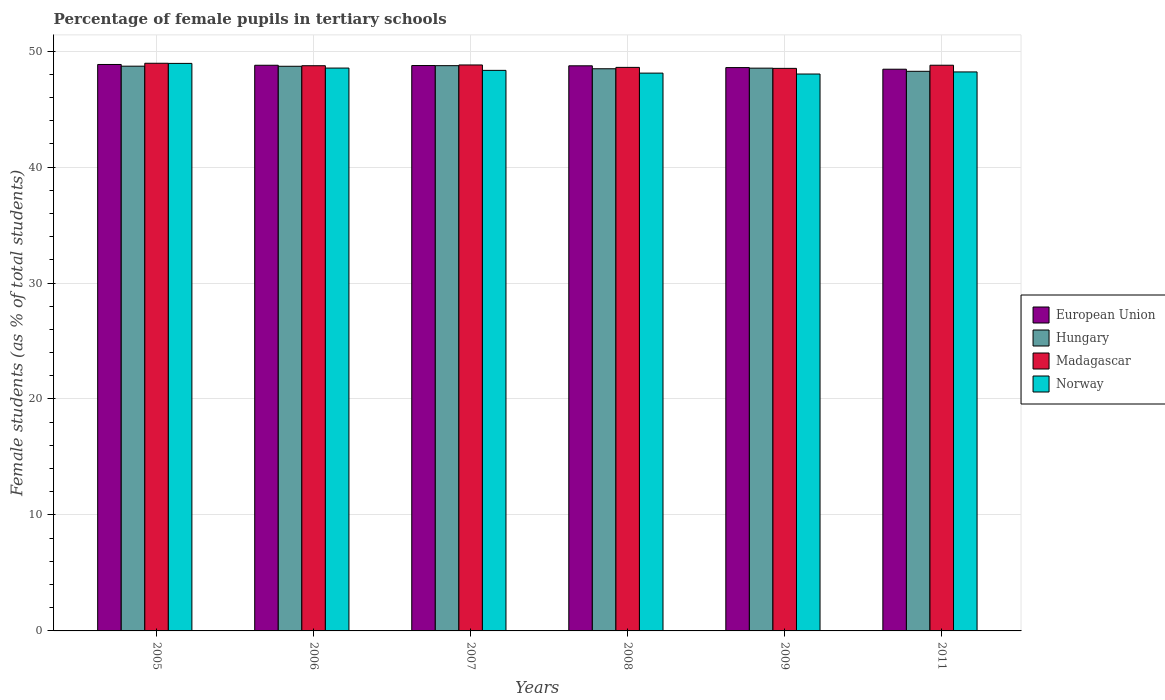How many different coloured bars are there?
Your response must be concise. 4. What is the label of the 4th group of bars from the left?
Keep it short and to the point. 2008. In how many cases, is the number of bars for a given year not equal to the number of legend labels?
Your response must be concise. 0. What is the percentage of female pupils in tertiary schools in Hungary in 2009?
Make the answer very short. 48.53. Across all years, what is the maximum percentage of female pupils in tertiary schools in Hungary?
Provide a succinct answer. 48.74. Across all years, what is the minimum percentage of female pupils in tertiary schools in Madagascar?
Ensure brevity in your answer.  48.51. In which year was the percentage of female pupils in tertiary schools in European Union maximum?
Your answer should be very brief. 2005. What is the total percentage of female pupils in tertiary schools in European Union in the graph?
Offer a terse response. 292.13. What is the difference between the percentage of female pupils in tertiary schools in European Union in 2005 and that in 2006?
Your answer should be compact. 0.07. What is the difference between the percentage of female pupils in tertiary schools in European Union in 2011 and the percentage of female pupils in tertiary schools in Madagascar in 2005?
Your answer should be very brief. -0.51. What is the average percentage of female pupils in tertiary schools in European Union per year?
Offer a very short reply. 48.69. In the year 2007, what is the difference between the percentage of female pupils in tertiary schools in Madagascar and percentage of female pupils in tertiary schools in European Union?
Provide a short and direct response. 0.05. In how many years, is the percentage of female pupils in tertiary schools in Norway greater than 14 %?
Make the answer very short. 6. What is the ratio of the percentage of female pupils in tertiary schools in Madagascar in 2006 to that in 2008?
Your answer should be very brief. 1. Is the difference between the percentage of female pupils in tertiary schools in Madagascar in 2006 and 2007 greater than the difference between the percentage of female pupils in tertiary schools in European Union in 2006 and 2007?
Offer a very short reply. No. What is the difference between the highest and the second highest percentage of female pupils in tertiary schools in Madagascar?
Give a very brief answer. 0.15. What is the difference between the highest and the lowest percentage of female pupils in tertiary schools in Hungary?
Your response must be concise. 0.49. In how many years, is the percentage of female pupils in tertiary schools in Hungary greater than the average percentage of female pupils in tertiary schools in Hungary taken over all years?
Provide a succinct answer. 3. Is the sum of the percentage of female pupils in tertiary schools in Madagascar in 2008 and 2009 greater than the maximum percentage of female pupils in tertiary schools in European Union across all years?
Make the answer very short. Yes. What does the 3rd bar from the left in 2006 represents?
Your answer should be compact. Madagascar. What does the 2nd bar from the right in 2007 represents?
Your answer should be very brief. Madagascar. Does the graph contain any zero values?
Provide a short and direct response. No. Does the graph contain grids?
Your response must be concise. Yes. How many legend labels are there?
Give a very brief answer. 4. What is the title of the graph?
Offer a very short reply. Percentage of female pupils in tertiary schools. What is the label or title of the Y-axis?
Your answer should be compact. Female students (as % of total students). What is the Female students (as % of total students) of European Union in 2005?
Offer a very short reply. 48.85. What is the Female students (as % of total students) in Hungary in 2005?
Give a very brief answer. 48.7. What is the Female students (as % of total students) in Madagascar in 2005?
Your answer should be very brief. 48.95. What is the Female students (as % of total students) of Norway in 2005?
Keep it short and to the point. 48.94. What is the Female students (as % of total students) in European Union in 2006?
Ensure brevity in your answer.  48.78. What is the Female students (as % of total students) of Hungary in 2006?
Your response must be concise. 48.69. What is the Female students (as % of total students) of Madagascar in 2006?
Keep it short and to the point. 48.74. What is the Female students (as % of total students) in Norway in 2006?
Your response must be concise. 48.54. What is the Female students (as % of total students) in European Union in 2007?
Keep it short and to the point. 48.75. What is the Female students (as % of total students) in Hungary in 2007?
Give a very brief answer. 48.74. What is the Female students (as % of total students) of Madagascar in 2007?
Your response must be concise. 48.8. What is the Female students (as % of total students) of Norway in 2007?
Give a very brief answer. 48.34. What is the Female students (as % of total students) of European Union in 2008?
Offer a terse response. 48.73. What is the Female students (as % of total students) of Hungary in 2008?
Give a very brief answer. 48.48. What is the Female students (as % of total students) in Madagascar in 2008?
Your response must be concise. 48.6. What is the Female students (as % of total students) in Norway in 2008?
Make the answer very short. 48.1. What is the Female students (as % of total students) of European Union in 2009?
Offer a very short reply. 48.58. What is the Female students (as % of total students) in Hungary in 2009?
Provide a short and direct response. 48.53. What is the Female students (as % of total students) of Madagascar in 2009?
Provide a short and direct response. 48.51. What is the Female students (as % of total students) of Norway in 2009?
Keep it short and to the point. 48.02. What is the Female students (as % of total students) in European Union in 2011?
Ensure brevity in your answer.  48.44. What is the Female students (as % of total students) in Hungary in 2011?
Provide a succinct answer. 48.26. What is the Female students (as % of total students) of Madagascar in 2011?
Provide a succinct answer. 48.78. What is the Female students (as % of total students) of Norway in 2011?
Your response must be concise. 48.2. Across all years, what is the maximum Female students (as % of total students) of European Union?
Give a very brief answer. 48.85. Across all years, what is the maximum Female students (as % of total students) of Hungary?
Offer a terse response. 48.74. Across all years, what is the maximum Female students (as % of total students) of Madagascar?
Give a very brief answer. 48.95. Across all years, what is the maximum Female students (as % of total students) of Norway?
Your answer should be compact. 48.94. Across all years, what is the minimum Female students (as % of total students) of European Union?
Provide a short and direct response. 48.44. Across all years, what is the minimum Female students (as % of total students) of Hungary?
Your response must be concise. 48.26. Across all years, what is the minimum Female students (as % of total students) in Madagascar?
Your answer should be compact. 48.51. Across all years, what is the minimum Female students (as % of total students) in Norway?
Offer a terse response. 48.02. What is the total Female students (as % of total students) of European Union in the graph?
Your answer should be very brief. 292.13. What is the total Female students (as % of total students) of Hungary in the graph?
Your answer should be very brief. 291.4. What is the total Female students (as % of total students) of Madagascar in the graph?
Your answer should be compact. 292.38. What is the total Female students (as % of total students) in Norway in the graph?
Keep it short and to the point. 290.14. What is the difference between the Female students (as % of total students) of European Union in 2005 and that in 2006?
Your answer should be compact. 0.07. What is the difference between the Female students (as % of total students) of Hungary in 2005 and that in 2006?
Ensure brevity in your answer.  0.01. What is the difference between the Female students (as % of total students) in Madagascar in 2005 and that in 2006?
Offer a terse response. 0.21. What is the difference between the Female students (as % of total students) in Norway in 2005 and that in 2006?
Offer a very short reply. 0.4. What is the difference between the Female students (as % of total students) in European Union in 2005 and that in 2007?
Offer a terse response. 0.09. What is the difference between the Female students (as % of total students) in Hungary in 2005 and that in 2007?
Offer a terse response. -0.04. What is the difference between the Female students (as % of total students) of Madagascar in 2005 and that in 2007?
Give a very brief answer. 0.15. What is the difference between the Female students (as % of total students) of Norway in 2005 and that in 2007?
Offer a terse response. 0.6. What is the difference between the Female students (as % of total students) in European Union in 2005 and that in 2008?
Give a very brief answer. 0.12. What is the difference between the Female students (as % of total students) of Hungary in 2005 and that in 2008?
Give a very brief answer. 0.22. What is the difference between the Female students (as % of total students) in Madagascar in 2005 and that in 2008?
Provide a short and direct response. 0.36. What is the difference between the Female students (as % of total students) in Norway in 2005 and that in 2008?
Your response must be concise. 0.84. What is the difference between the Female students (as % of total students) in European Union in 2005 and that in 2009?
Your answer should be very brief. 0.27. What is the difference between the Female students (as % of total students) of Hungary in 2005 and that in 2009?
Give a very brief answer. 0.17. What is the difference between the Female students (as % of total students) in Madagascar in 2005 and that in 2009?
Provide a succinct answer. 0.44. What is the difference between the Female students (as % of total students) of Norway in 2005 and that in 2009?
Offer a very short reply. 0.92. What is the difference between the Female students (as % of total students) in European Union in 2005 and that in 2011?
Keep it short and to the point. 0.41. What is the difference between the Female students (as % of total students) in Hungary in 2005 and that in 2011?
Offer a very short reply. 0.44. What is the difference between the Female students (as % of total students) in Madagascar in 2005 and that in 2011?
Give a very brief answer. 0.17. What is the difference between the Female students (as % of total students) of Norway in 2005 and that in 2011?
Ensure brevity in your answer.  0.74. What is the difference between the Female students (as % of total students) in European Union in 2006 and that in 2007?
Make the answer very short. 0.02. What is the difference between the Female students (as % of total students) in Hungary in 2006 and that in 2007?
Ensure brevity in your answer.  -0.05. What is the difference between the Female students (as % of total students) in Madagascar in 2006 and that in 2007?
Your answer should be very brief. -0.07. What is the difference between the Female students (as % of total students) in Norway in 2006 and that in 2007?
Keep it short and to the point. 0.2. What is the difference between the Female students (as % of total students) in European Union in 2006 and that in 2008?
Provide a short and direct response. 0.05. What is the difference between the Female students (as % of total students) in Hungary in 2006 and that in 2008?
Your response must be concise. 0.21. What is the difference between the Female students (as % of total students) in Madagascar in 2006 and that in 2008?
Make the answer very short. 0.14. What is the difference between the Female students (as % of total students) of Norway in 2006 and that in 2008?
Give a very brief answer. 0.43. What is the difference between the Female students (as % of total students) of European Union in 2006 and that in 2009?
Provide a succinct answer. 0.2. What is the difference between the Female students (as % of total students) of Hungary in 2006 and that in 2009?
Make the answer very short. 0.16. What is the difference between the Female students (as % of total students) in Madagascar in 2006 and that in 2009?
Offer a very short reply. 0.23. What is the difference between the Female students (as % of total students) in Norway in 2006 and that in 2009?
Ensure brevity in your answer.  0.51. What is the difference between the Female students (as % of total students) in European Union in 2006 and that in 2011?
Offer a very short reply. 0.34. What is the difference between the Female students (as % of total students) of Hungary in 2006 and that in 2011?
Provide a short and direct response. 0.43. What is the difference between the Female students (as % of total students) in Madagascar in 2006 and that in 2011?
Your answer should be very brief. -0.04. What is the difference between the Female students (as % of total students) in Norway in 2006 and that in 2011?
Offer a very short reply. 0.33. What is the difference between the Female students (as % of total students) of European Union in 2007 and that in 2008?
Your answer should be very brief. 0.02. What is the difference between the Female students (as % of total students) in Hungary in 2007 and that in 2008?
Offer a very short reply. 0.27. What is the difference between the Female students (as % of total students) in Madagascar in 2007 and that in 2008?
Keep it short and to the point. 0.21. What is the difference between the Female students (as % of total students) in Norway in 2007 and that in 2008?
Give a very brief answer. 0.24. What is the difference between the Female students (as % of total students) of European Union in 2007 and that in 2009?
Your response must be concise. 0.18. What is the difference between the Female students (as % of total students) in Hungary in 2007 and that in 2009?
Make the answer very short. 0.21. What is the difference between the Female students (as % of total students) of Madagascar in 2007 and that in 2009?
Provide a succinct answer. 0.29. What is the difference between the Female students (as % of total students) in Norway in 2007 and that in 2009?
Provide a succinct answer. 0.32. What is the difference between the Female students (as % of total students) in European Union in 2007 and that in 2011?
Your answer should be very brief. 0.32. What is the difference between the Female students (as % of total students) in Hungary in 2007 and that in 2011?
Your answer should be very brief. 0.49. What is the difference between the Female students (as % of total students) in Madagascar in 2007 and that in 2011?
Your response must be concise. 0.02. What is the difference between the Female students (as % of total students) in Norway in 2007 and that in 2011?
Make the answer very short. 0.14. What is the difference between the Female students (as % of total students) in European Union in 2008 and that in 2009?
Give a very brief answer. 0.15. What is the difference between the Female students (as % of total students) in Hungary in 2008 and that in 2009?
Ensure brevity in your answer.  -0.05. What is the difference between the Female students (as % of total students) of Madagascar in 2008 and that in 2009?
Ensure brevity in your answer.  0.09. What is the difference between the Female students (as % of total students) of Norway in 2008 and that in 2009?
Make the answer very short. 0.08. What is the difference between the Female students (as % of total students) in European Union in 2008 and that in 2011?
Your response must be concise. 0.29. What is the difference between the Female students (as % of total students) in Hungary in 2008 and that in 2011?
Offer a terse response. 0.22. What is the difference between the Female students (as % of total students) of Madagascar in 2008 and that in 2011?
Make the answer very short. -0.19. What is the difference between the Female students (as % of total students) in Norway in 2008 and that in 2011?
Give a very brief answer. -0.1. What is the difference between the Female students (as % of total students) in European Union in 2009 and that in 2011?
Ensure brevity in your answer.  0.14. What is the difference between the Female students (as % of total students) in Hungary in 2009 and that in 2011?
Offer a very short reply. 0.27. What is the difference between the Female students (as % of total students) in Madagascar in 2009 and that in 2011?
Your response must be concise. -0.27. What is the difference between the Female students (as % of total students) in Norway in 2009 and that in 2011?
Provide a short and direct response. -0.18. What is the difference between the Female students (as % of total students) in European Union in 2005 and the Female students (as % of total students) in Hungary in 2006?
Ensure brevity in your answer.  0.16. What is the difference between the Female students (as % of total students) in European Union in 2005 and the Female students (as % of total students) in Madagascar in 2006?
Provide a succinct answer. 0.11. What is the difference between the Female students (as % of total students) in European Union in 2005 and the Female students (as % of total students) in Norway in 2006?
Offer a terse response. 0.31. What is the difference between the Female students (as % of total students) of Hungary in 2005 and the Female students (as % of total students) of Madagascar in 2006?
Your response must be concise. -0.04. What is the difference between the Female students (as % of total students) of Hungary in 2005 and the Female students (as % of total students) of Norway in 2006?
Make the answer very short. 0.16. What is the difference between the Female students (as % of total students) of Madagascar in 2005 and the Female students (as % of total students) of Norway in 2006?
Keep it short and to the point. 0.42. What is the difference between the Female students (as % of total students) of European Union in 2005 and the Female students (as % of total students) of Hungary in 2007?
Your response must be concise. 0.1. What is the difference between the Female students (as % of total students) in European Union in 2005 and the Female students (as % of total students) in Madagascar in 2007?
Your answer should be compact. 0.04. What is the difference between the Female students (as % of total students) of European Union in 2005 and the Female students (as % of total students) of Norway in 2007?
Give a very brief answer. 0.51. What is the difference between the Female students (as % of total students) in Hungary in 2005 and the Female students (as % of total students) in Madagascar in 2007?
Offer a terse response. -0.1. What is the difference between the Female students (as % of total students) in Hungary in 2005 and the Female students (as % of total students) in Norway in 2007?
Offer a very short reply. 0.36. What is the difference between the Female students (as % of total students) in Madagascar in 2005 and the Female students (as % of total students) in Norway in 2007?
Your response must be concise. 0.61. What is the difference between the Female students (as % of total students) in European Union in 2005 and the Female students (as % of total students) in Hungary in 2008?
Provide a succinct answer. 0.37. What is the difference between the Female students (as % of total students) in European Union in 2005 and the Female students (as % of total students) in Madagascar in 2008?
Offer a very short reply. 0.25. What is the difference between the Female students (as % of total students) of European Union in 2005 and the Female students (as % of total students) of Norway in 2008?
Your answer should be compact. 0.75. What is the difference between the Female students (as % of total students) of Hungary in 2005 and the Female students (as % of total students) of Madagascar in 2008?
Your response must be concise. 0.1. What is the difference between the Female students (as % of total students) in Hungary in 2005 and the Female students (as % of total students) in Norway in 2008?
Offer a terse response. 0.6. What is the difference between the Female students (as % of total students) in Madagascar in 2005 and the Female students (as % of total students) in Norway in 2008?
Offer a very short reply. 0.85. What is the difference between the Female students (as % of total students) in European Union in 2005 and the Female students (as % of total students) in Hungary in 2009?
Your response must be concise. 0.32. What is the difference between the Female students (as % of total students) of European Union in 2005 and the Female students (as % of total students) of Madagascar in 2009?
Keep it short and to the point. 0.34. What is the difference between the Female students (as % of total students) of European Union in 2005 and the Female students (as % of total students) of Norway in 2009?
Make the answer very short. 0.82. What is the difference between the Female students (as % of total students) in Hungary in 2005 and the Female students (as % of total students) in Madagascar in 2009?
Your answer should be compact. 0.19. What is the difference between the Female students (as % of total students) of Hungary in 2005 and the Female students (as % of total students) of Norway in 2009?
Offer a very short reply. 0.68. What is the difference between the Female students (as % of total students) of European Union in 2005 and the Female students (as % of total students) of Hungary in 2011?
Provide a short and direct response. 0.59. What is the difference between the Female students (as % of total students) in European Union in 2005 and the Female students (as % of total students) in Madagascar in 2011?
Keep it short and to the point. 0.06. What is the difference between the Female students (as % of total students) of European Union in 2005 and the Female students (as % of total students) of Norway in 2011?
Make the answer very short. 0.64. What is the difference between the Female students (as % of total students) in Hungary in 2005 and the Female students (as % of total students) in Madagascar in 2011?
Provide a short and direct response. -0.08. What is the difference between the Female students (as % of total students) in Hungary in 2005 and the Female students (as % of total students) in Norway in 2011?
Provide a succinct answer. 0.5. What is the difference between the Female students (as % of total students) in Madagascar in 2005 and the Female students (as % of total students) in Norway in 2011?
Keep it short and to the point. 0.75. What is the difference between the Female students (as % of total students) of European Union in 2006 and the Female students (as % of total students) of Hungary in 2007?
Offer a very short reply. 0.03. What is the difference between the Female students (as % of total students) in European Union in 2006 and the Female students (as % of total students) in Madagascar in 2007?
Your answer should be compact. -0.03. What is the difference between the Female students (as % of total students) of European Union in 2006 and the Female students (as % of total students) of Norway in 2007?
Provide a succinct answer. 0.44. What is the difference between the Female students (as % of total students) of Hungary in 2006 and the Female students (as % of total students) of Madagascar in 2007?
Give a very brief answer. -0.11. What is the difference between the Female students (as % of total students) of Hungary in 2006 and the Female students (as % of total students) of Norway in 2007?
Provide a succinct answer. 0.35. What is the difference between the Female students (as % of total students) in Madagascar in 2006 and the Female students (as % of total students) in Norway in 2007?
Offer a very short reply. 0.4. What is the difference between the Female students (as % of total students) of European Union in 2006 and the Female students (as % of total students) of Hungary in 2008?
Offer a terse response. 0.3. What is the difference between the Female students (as % of total students) in European Union in 2006 and the Female students (as % of total students) in Madagascar in 2008?
Make the answer very short. 0.18. What is the difference between the Female students (as % of total students) in European Union in 2006 and the Female students (as % of total students) in Norway in 2008?
Your answer should be very brief. 0.68. What is the difference between the Female students (as % of total students) of Hungary in 2006 and the Female students (as % of total students) of Madagascar in 2008?
Offer a terse response. 0.1. What is the difference between the Female students (as % of total students) of Hungary in 2006 and the Female students (as % of total students) of Norway in 2008?
Your answer should be very brief. 0.59. What is the difference between the Female students (as % of total students) in Madagascar in 2006 and the Female students (as % of total students) in Norway in 2008?
Offer a terse response. 0.64. What is the difference between the Female students (as % of total students) of European Union in 2006 and the Female students (as % of total students) of Hungary in 2009?
Ensure brevity in your answer.  0.25. What is the difference between the Female students (as % of total students) in European Union in 2006 and the Female students (as % of total students) in Madagascar in 2009?
Offer a very short reply. 0.27. What is the difference between the Female students (as % of total students) in European Union in 2006 and the Female students (as % of total students) in Norway in 2009?
Give a very brief answer. 0.76. What is the difference between the Female students (as % of total students) of Hungary in 2006 and the Female students (as % of total students) of Madagascar in 2009?
Give a very brief answer. 0.18. What is the difference between the Female students (as % of total students) in Hungary in 2006 and the Female students (as % of total students) in Norway in 2009?
Your answer should be very brief. 0.67. What is the difference between the Female students (as % of total students) of Madagascar in 2006 and the Female students (as % of total students) of Norway in 2009?
Your response must be concise. 0.72. What is the difference between the Female students (as % of total students) in European Union in 2006 and the Female students (as % of total students) in Hungary in 2011?
Give a very brief answer. 0.52. What is the difference between the Female students (as % of total students) in European Union in 2006 and the Female students (as % of total students) in Madagascar in 2011?
Make the answer very short. -0. What is the difference between the Female students (as % of total students) in European Union in 2006 and the Female students (as % of total students) in Norway in 2011?
Offer a very short reply. 0.58. What is the difference between the Female students (as % of total students) in Hungary in 2006 and the Female students (as % of total students) in Madagascar in 2011?
Provide a short and direct response. -0.09. What is the difference between the Female students (as % of total students) of Hungary in 2006 and the Female students (as % of total students) of Norway in 2011?
Your response must be concise. 0.49. What is the difference between the Female students (as % of total students) of Madagascar in 2006 and the Female students (as % of total students) of Norway in 2011?
Provide a short and direct response. 0.53. What is the difference between the Female students (as % of total students) in European Union in 2007 and the Female students (as % of total students) in Hungary in 2008?
Give a very brief answer. 0.28. What is the difference between the Female students (as % of total students) of European Union in 2007 and the Female students (as % of total students) of Madagascar in 2008?
Provide a succinct answer. 0.16. What is the difference between the Female students (as % of total students) of European Union in 2007 and the Female students (as % of total students) of Norway in 2008?
Provide a succinct answer. 0.65. What is the difference between the Female students (as % of total students) in Hungary in 2007 and the Female students (as % of total students) in Madagascar in 2008?
Offer a very short reply. 0.15. What is the difference between the Female students (as % of total students) in Hungary in 2007 and the Female students (as % of total students) in Norway in 2008?
Give a very brief answer. 0.64. What is the difference between the Female students (as % of total students) in Madagascar in 2007 and the Female students (as % of total students) in Norway in 2008?
Provide a short and direct response. 0.7. What is the difference between the Female students (as % of total students) in European Union in 2007 and the Female students (as % of total students) in Hungary in 2009?
Make the answer very short. 0.22. What is the difference between the Female students (as % of total students) in European Union in 2007 and the Female students (as % of total students) in Madagascar in 2009?
Ensure brevity in your answer.  0.24. What is the difference between the Female students (as % of total students) in European Union in 2007 and the Female students (as % of total students) in Norway in 2009?
Provide a short and direct response. 0.73. What is the difference between the Female students (as % of total students) in Hungary in 2007 and the Female students (as % of total students) in Madagascar in 2009?
Provide a succinct answer. 0.23. What is the difference between the Female students (as % of total students) in Hungary in 2007 and the Female students (as % of total students) in Norway in 2009?
Provide a succinct answer. 0.72. What is the difference between the Female students (as % of total students) of Madagascar in 2007 and the Female students (as % of total students) of Norway in 2009?
Offer a terse response. 0.78. What is the difference between the Female students (as % of total students) of European Union in 2007 and the Female students (as % of total students) of Hungary in 2011?
Offer a very short reply. 0.5. What is the difference between the Female students (as % of total students) in European Union in 2007 and the Female students (as % of total students) in Madagascar in 2011?
Your response must be concise. -0.03. What is the difference between the Female students (as % of total students) of European Union in 2007 and the Female students (as % of total students) of Norway in 2011?
Provide a short and direct response. 0.55. What is the difference between the Female students (as % of total students) of Hungary in 2007 and the Female students (as % of total students) of Madagascar in 2011?
Keep it short and to the point. -0.04. What is the difference between the Female students (as % of total students) in Hungary in 2007 and the Female students (as % of total students) in Norway in 2011?
Offer a terse response. 0.54. What is the difference between the Female students (as % of total students) in Madagascar in 2007 and the Female students (as % of total students) in Norway in 2011?
Offer a terse response. 0.6. What is the difference between the Female students (as % of total students) of European Union in 2008 and the Female students (as % of total students) of Hungary in 2009?
Your answer should be very brief. 0.2. What is the difference between the Female students (as % of total students) of European Union in 2008 and the Female students (as % of total students) of Madagascar in 2009?
Your answer should be very brief. 0.22. What is the difference between the Female students (as % of total students) of European Union in 2008 and the Female students (as % of total students) of Norway in 2009?
Provide a succinct answer. 0.71. What is the difference between the Female students (as % of total students) in Hungary in 2008 and the Female students (as % of total students) in Madagascar in 2009?
Ensure brevity in your answer.  -0.03. What is the difference between the Female students (as % of total students) of Hungary in 2008 and the Female students (as % of total students) of Norway in 2009?
Offer a very short reply. 0.45. What is the difference between the Female students (as % of total students) of Madagascar in 2008 and the Female students (as % of total students) of Norway in 2009?
Make the answer very short. 0.57. What is the difference between the Female students (as % of total students) of European Union in 2008 and the Female students (as % of total students) of Hungary in 2011?
Make the answer very short. 0.47. What is the difference between the Female students (as % of total students) in European Union in 2008 and the Female students (as % of total students) in Madagascar in 2011?
Offer a terse response. -0.05. What is the difference between the Female students (as % of total students) of European Union in 2008 and the Female students (as % of total students) of Norway in 2011?
Provide a succinct answer. 0.53. What is the difference between the Female students (as % of total students) of Hungary in 2008 and the Female students (as % of total students) of Madagascar in 2011?
Provide a short and direct response. -0.3. What is the difference between the Female students (as % of total students) in Hungary in 2008 and the Female students (as % of total students) in Norway in 2011?
Give a very brief answer. 0.27. What is the difference between the Female students (as % of total students) of Madagascar in 2008 and the Female students (as % of total students) of Norway in 2011?
Your answer should be very brief. 0.39. What is the difference between the Female students (as % of total students) in European Union in 2009 and the Female students (as % of total students) in Hungary in 2011?
Provide a short and direct response. 0.32. What is the difference between the Female students (as % of total students) in European Union in 2009 and the Female students (as % of total students) in Madagascar in 2011?
Your answer should be very brief. -0.2. What is the difference between the Female students (as % of total students) of European Union in 2009 and the Female students (as % of total students) of Norway in 2011?
Offer a very short reply. 0.37. What is the difference between the Female students (as % of total students) in Hungary in 2009 and the Female students (as % of total students) in Madagascar in 2011?
Your answer should be very brief. -0.25. What is the difference between the Female students (as % of total students) of Hungary in 2009 and the Female students (as % of total students) of Norway in 2011?
Provide a short and direct response. 0.33. What is the difference between the Female students (as % of total students) in Madagascar in 2009 and the Female students (as % of total students) in Norway in 2011?
Provide a short and direct response. 0.31. What is the average Female students (as % of total students) of European Union per year?
Make the answer very short. 48.69. What is the average Female students (as % of total students) in Hungary per year?
Offer a very short reply. 48.57. What is the average Female students (as % of total students) of Madagascar per year?
Your answer should be very brief. 48.73. What is the average Female students (as % of total students) in Norway per year?
Provide a short and direct response. 48.36. In the year 2005, what is the difference between the Female students (as % of total students) in European Union and Female students (as % of total students) in Hungary?
Keep it short and to the point. 0.15. In the year 2005, what is the difference between the Female students (as % of total students) in European Union and Female students (as % of total students) in Madagascar?
Your answer should be very brief. -0.1. In the year 2005, what is the difference between the Female students (as % of total students) of European Union and Female students (as % of total students) of Norway?
Make the answer very short. -0.09. In the year 2005, what is the difference between the Female students (as % of total students) in Hungary and Female students (as % of total students) in Madagascar?
Offer a terse response. -0.25. In the year 2005, what is the difference between the Female students (as % of total students) in Hungary and Female students (as % of total students) in Norway?
Provide a short and direct response. -0.24. In the year 2005, what is the difference between the Female students (as % of total students) in Madagascar and Female students (as % of total students) in Norway?
Your answer should be very brief. 0.01. In the year 2006, what is the difference between the Female students (as % of total students) of European Union and Female students (as % of total students) of Hungary?
Provide a succinct answer. 0.09. In the year 2006, what is the difference between the Female students (as % of total students) of European Union and Female students (as % of total students) of Madagascar?
Make the answer very short. 0.04. In the year 2006, what is the difference between the Female students (as % of total students) in European Union and Female students (as % of total students) in Norway?
Offer a very short reply. 0.24. In the year 2006, what is the difference between the Female students (as % of total students) in Hungary and Female students (as % of total students) in Madagascar?
Offer a very short reply. -0.05. In the year 2006, what is the difference between the Female students (as % of total students) of Hungary and Female students (as % of total students) of Norway?
Your response must be concise. 0.16. In the year 2006, what is the difference between the Female students (as % of total students) in Madagascar and Female students (as % of total students) in Norway?
Make the answer very short. 0.2. In the year 2007, what is the difference between the Female students (as % of total students) of European Union and Female students (as % of total students) of Hungary?
Provide a short and direct response. 0.01. In the year 2007, what is the difference between the Female students (as % of total students) of European Union and Female students (as % of total students) of Madagascar?
Make the answer very short. -0.05. In the year 2007, what is the difference between the Female students (as % of total students) of European Union and Female students (as % of total students) of Norway?
Your response must be concise. 0.42. In the year 2007, what is the difference between the Female students (as % of total students) of Hungary and Female students (as % of total students) of Madagascar?
Your response must be concise. -0.06. In the year 2007, what is the difference between the Female students (as % of total students) of Hungary and Female students (as % of total students) of Norway?
Offer a very short reply. 0.41. In the year 2007, what is the difference between the Female students (as % of total students) in Madagascar and Female students (as % of total students) in Norway?
Your response must be concise. 0.47. In the year 2008, what is the difference between the Female students (as % of total students) in European Union and Female students (as % of total students) in Hungary?
Offer a very short reply. 0.25. In the year 2008, what is the difference between the Female students (as % of total students) in European Union and Female students (as % of total students) in Madagascar?
Keep it short and to the point. 0.14. In the year 2008, what is the difference between the Female students (as % of total students) in European Union and Female students (as % of total students) in Norway?
Ensure brevity in your answer.  0.63. In the year 2008, what is the difference between the Female students (as % of total students) of Hungary and Female students (as % of total students) of Madagascar?
Offer a very short reply. -0.12. In the year 2008, what is the difference between the Female students (as % of total students) of Hungary and Female students (as % of total students) of Norway?
Give a very brief answer. 0.38. In the year 2008, what is the difference between the Female students (as % of total students) of Madagascar and Female students (as % of total students) of Norway?
Offer a very short reply. 0.49. In the year 2009, what is the difference between the Female students (as % of total students) in European Union and Female students (as % of total students) in Hungary?
Ensure brevity in your answer.  0.05. In the year 2009, what is the difference between the Female students (as % of total students) of European Union and Female students (as % of total students) of Madagascar?
Provide a short and direct response. 0.07. In the year 2009, what is the difference between the Female students (as % of total students) of European Union and Female students (as % of total students) of Norway?
Give a very brief answer. 0.56. In the year 2009, what is the difference between the Female students (as % of total students) of Hungary and Female students (as % of total students) of Madagascar?
Provide a succinct answer. 0.02. In the year 2009, what is the difference between the Female students (as % of total students) of Hungary and Female students (as % of total students) of Norway?
Offer a terse response. 0.51. In the year 2009, what is the difference between the Female students (as % of total students) in Madagascar and Female students (as % of total students) in Norway?
Ensure brevity in your answer.  0.49. In the year 2011, what is the difference between the Female students (as % of total students) in European Union and Female students (as % of total students) in Hungary?
Make the answer very short. 0.18. In the year 2011, what is the difference between the Female students (as % of total students) in European Union and Female students (as % of total students) in Madagascar?
Your answer should be compact. -0.34. In the year 2011, what is the difference between the Female students (as % of total students) of European Union and Female students (as % of total students) of Norway?
Your answer should be compact. 0.23. In the year 2011, what is the difference between the Female students (as % of total students) in Hungary and Female students (as % of total students) in Madagascar?
Offer a very short reply. -0.52. In the year 2011, what is the difference between the Female students (as % of total students) of Hungary and Female students (as % of total students) of Norway?
Keep it short and to the point. 0.05. In the year 2011, what is the difference between the Female students (as % of total students) of Madagascar and Female students (as % of total students) of Norway?
Make the answer very short. 0.58. What is the ratio of the Female students (as % of total students) of European Union in 2005 to that in 2006?
Your answer should be very brief. 1. What is the ratio of the Female students (as % of total students) in Norway in 2005 to that in 2006?
Ensure brevity in your answer.  1.01. What is the ratio of the Female students (as % of total students) in Hungary in 2005 to that in 2007?
Provide a succinct answer. 1. What is the ratio of the Female students (as % of total students) of Madagascar in 2005 to that in 2007?
Give a very brief answer. 1. What is the ratio of the Female students (as % of total students) of Norway in 2005 to that in 2007?
Your answer should be very brief. 1.01. What is the ratio of the Female students (as % of total students) in Hungary in 2005 to that in 2008?
Offer a very short reply. 1. What is the ratio of the Female students (as % of total students) in Madagascar in 2005 to that in 2008?
Offer a very short reply. 1.01. What is the ratio of the Female students (as % of total students) in Norway in 2005 to that in 2008?
Ensure brevity in your answer.  1.02. What is the ratio of the Female students (as % of total students) in Hungary in 2005 to that in 2009?
Make the answer very short. 1. What is the ratio of the Female students (as % of total students) of Madagascar in 2005 to that in 2009?
Give a very brief answer. 1.01. What is the ratio of the Female students (as % of total students) in Norway in 2005 to that in 2009?
Your answer should be compact. 1.02. What is the ratio of the Female students (as % of total students) in European Union in 2005 to that in 2011?
Give a very brief answer. 1.01. What is the ratio of the Female students (as % of total students) in Hungary in 2005 to that in 2011?
Ensure brevity in your answer.  1.01. What is the ratio of the Female students (as % of total students) of Norway in 2005 to that in 2011?
Offer a terse response. 1.02. What is the ratio of the Female students (as % of total students) of Madagascar in 2006 to that in 2007?
Ensure brevity in your answer.  1. What is the ratio of the Female students (as % of total students) of European Union in 2006 to that in 2008?
Your response must be concise. 1. What is the ratio of the Female students (as % of total students) of Hungary in 2006 to that in 2008?
Give a very brief answer. 1. What is the ratio of the Female students (as % of total students) of European Union in 2006 to that in 2009?
Provide a short and direct response. 1. What is the ratio of the Female students (as % of total students) of Madagascar in 2006 to that in 2009?
Provide a short and direct response. 1. What is the ratio of the Female students (as % of total students) in Norway in 2006 to that in 2009?
Give a very brief answer. 1.01. What is the ratio of the Female students (as % of total students) in European Union in 2006 to that in 2011?
Offer a very short reply. 1.01. What is the ratio of the Female students (as % of total students) of Hungary in 2006 to that in 2011?
Make the answer very short. 1.01. What is the ratio of the Female students (as % of total students) in Norway in 2006 to that in 2011?
Make the answer very short. 1.01. What is the ratio of the Female students (as % of total students) in Norway in 2007 to that in 2009?
Your answer should be compact. 1.01. What is the ratio of the Female students (as % of total students) in Hungary in 2007 to that in 2011?
Ensure brevity in your answer.  1.01. What is the ratio of the Female students (as % of total students) of Hungary in 2008 to that in 2009?
Your response must be concise. 1. What is the ratio of the Female students (as % of total students) of Norway in 2008 to that in 2009?
Offer a very short reply. 1. What is the ratio of the Female students (as % of total students) in Hungary in 2008 to that in 2011?
Offer a very short reply. 1. What is the ratio of the Female students (as % of total students) of Madagascar in 2008 to that in 2011?
Give a very brief answer. 1. What is the ratio of the Female students (as % of total students) in European Union in 2009 to that in 2011?
Keep it short and to the point. 1. What is the ratio of the Female students (as % of total students) in Hungary in 2009 to that in 2011?
Keep it short and to the point. 1.01. What is the ratio of the Female students (as % of total students) of Madagascar in 2009 to that in 2011?
Give a very brief answer. 0.99. What is the ratio of the Female students (as % of total students) of Norway in 2009 to that in 2011?
Your response must be concise. 1. What is the difference between the highest and the second highest Female students (as % of total students) in European Union?
Keep it short and to the point. 0.07. What is the difference between the highest and the second highest Female students (as % of total students) of Hungary?
Offer a very short reply. 0.04. What is the difference between the highest and the second highest Female students (as % of total students) in Madagascar?
Give a very brief answer. 0.15. What is the difference between the highest and the second highest Female students (as % of total students) in Norway?
Your response must be concise. 0.4. What is the difference between the highest and the lowest Female students (as % of total students) in European Union?
Your answer should be compact. 0.41. What is the difference between the highest and the lowest Female students (as % of total students) of Hungary?
Your answer should be compact. 0.49. What is the difference between the highest and the lowest Female students (as % of total students) of Madagascar?
Keep it short and to the point. 0.44. What is the difference between the highest and the lowest Female students (as % of total students) of Norway?
Your answer should be very brief. 0.92. 